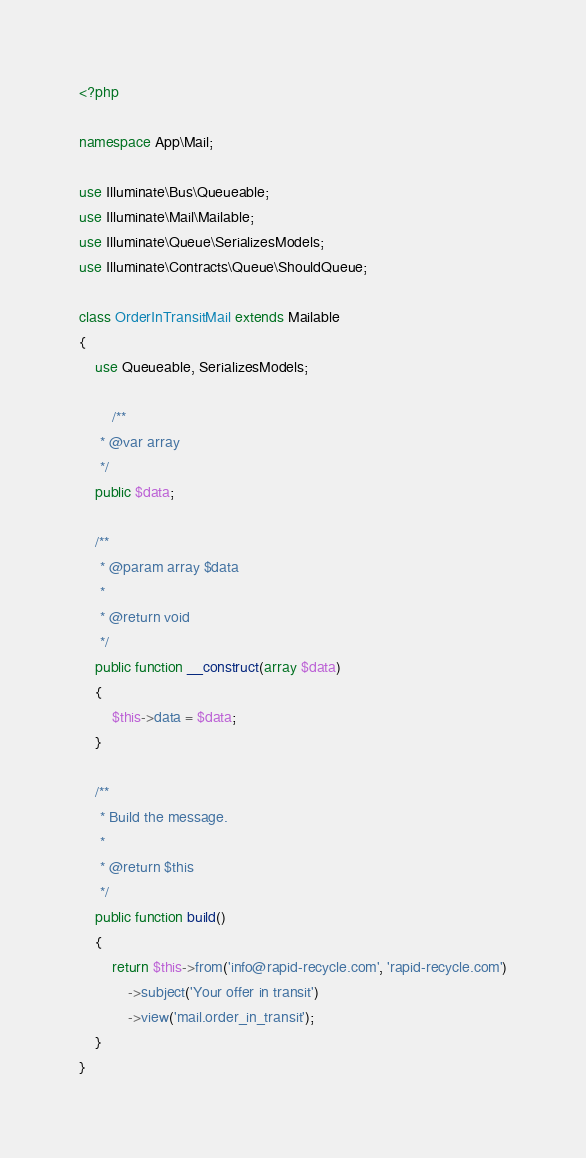Convert code to text. <code><loc_0><loc_0><loc_500><loc_500><_PHP_><?php

namespace App\Mail;

use Illuminate\Bus\Queueable;
use Illuminate\Mail\Mailable;
use Illuminate\Queue\SerializesModels;
use Illuminate\Contracts\Queue\ShouldQueue;

class OrderInTransitMail extends Mailable
{
    use Queueable, SerializesModels;

        /**
     * @var array
     */
    public $data;

    /**
     * @param array $data
     *
     * @return void
     */
    public function __construct(array $data)
    {
        $this->data = $data;
    }

    /**
     * Build the message.
     *
     * @return $this
     */
    public function build()
    {
        return $this->from('info@rapid-recycle.com', 'rapid-recycle.com')
            ->subject('Your offer in transit')
            ->view('mail.order_in_transit');
    }
}
</code> 